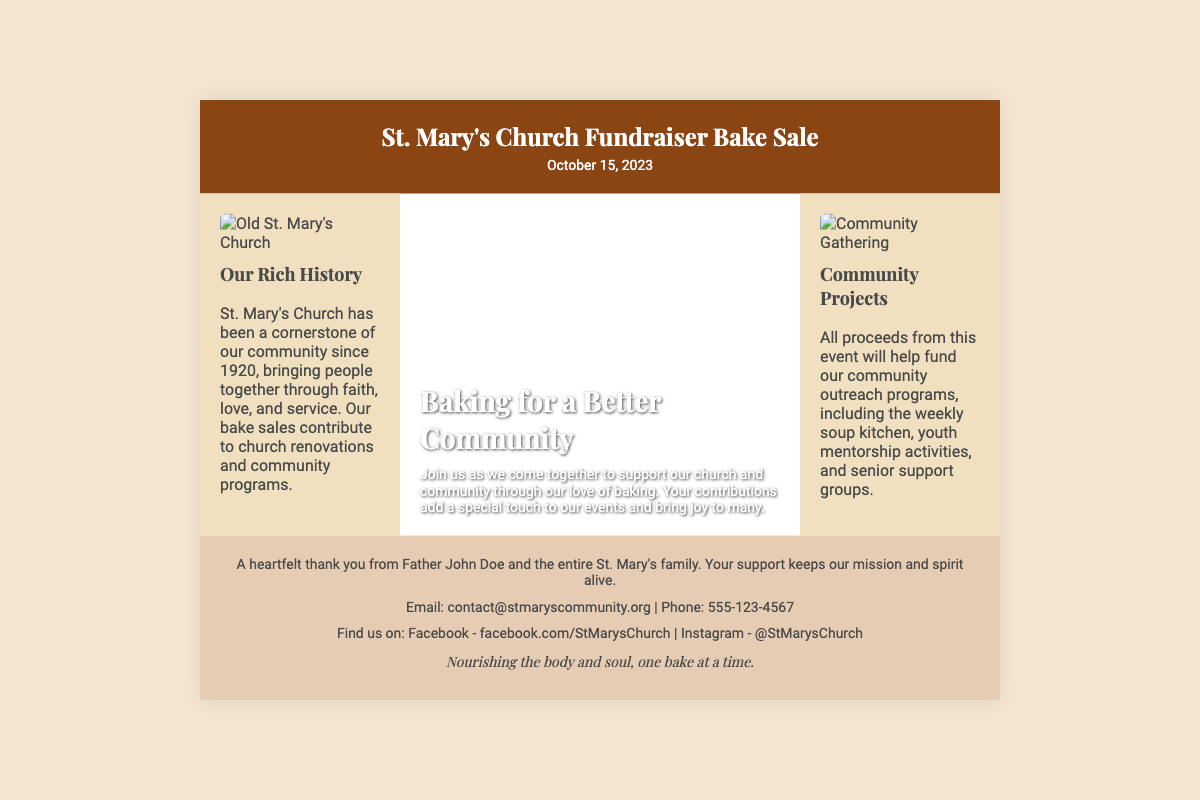What is the name of the event? The name of the event is mentioned in the header section of the document.
Answer: St. Mary's Church Fundraiser Bake Sale What is the date of the bake sale? The date of the bake sale is displayed right below the event name in the header.
Answer: October 15, 2023 Who is the main person mentioned in the footer? The footer contains a thank you message from a person associated with St. Mary's Church.
Answer: Father John Doe What are the proceeds from the bake sale used for? The document mentions the purpose of the proceeds in the right-side section.
Answer: Community outreach programs What image is featured on the left side? The left side of the packaging displays a specific image related to the church's history.
Answer: Old St. Mary's Church What is the slogan at the end of the document? The slogan is included in the footer and summarizes the church's mission.
Answer: Nourishing the body and soul, one bake at a time How long has St. Mary's Church been in the community? The document states the year when St. Mary's Church was established.
Answer: Since 1920 What is the title of the section in the middle of the packaging? The middle section introduces a theme related to the event.
Answer: Baking for a Better Community What is the background color of the header? The color of the header is specified in the style section and is visually consistent throughout the document.
Answer: #8b4513 